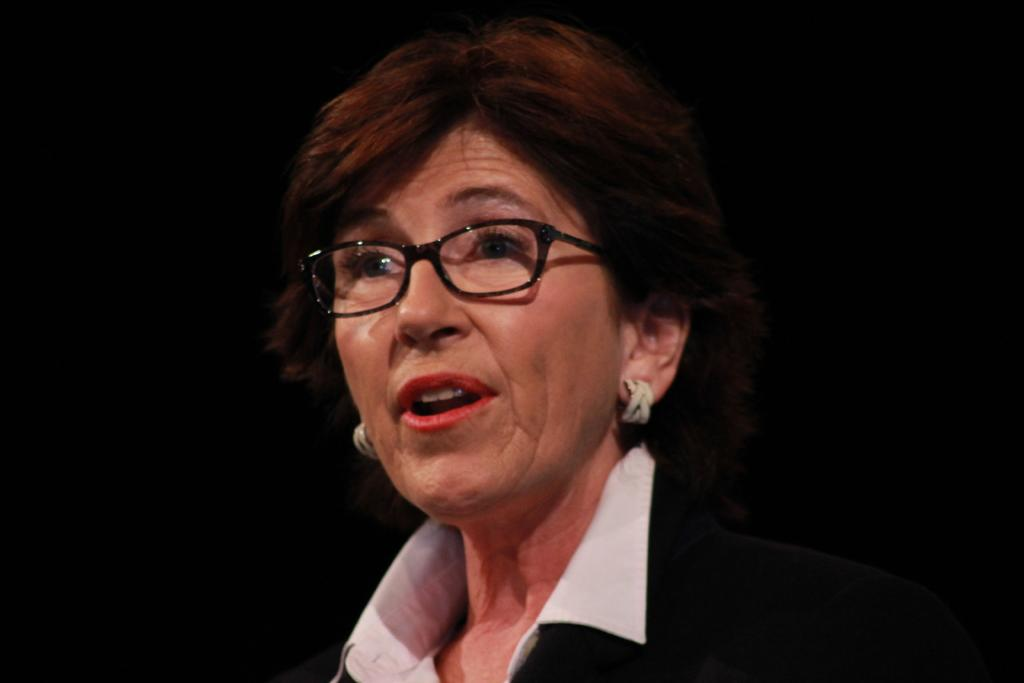What is the main subject of the image? The main subject of the image is a woman. Can you describe any accessories the woman is wearing? The woman is wearing glasses. What is the color of the background in the image? The background of the image is dark. What type of pancake is the woman eating in the image? There is no pancake present in the image. Is the woman in the image a member of the police force? There is no indication in the image that the woman is a member of the police force. 